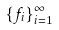Convert formula to latex. <formula><loc_0><loc_0><loc_500><loc_500>\{ f _ { i } \} _ { i = 1 } ^ { \infty }</formula> 